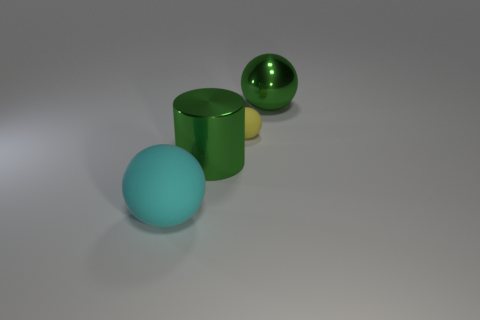Add 1 large green things. How many objects exist? 5 Subtract all cylinders. How many objects are left? 3 Add 4 small metallic cylinders. How many small metallic cylinders exist? 4 Subtract 0 gray blocks. How many objects are left? 4 Subtract all large cyan rubber things. Subtract all yellow matte balls. How many objects are left? 2 Add 3 cyan spheres. How many cyan spheres are left? 4 